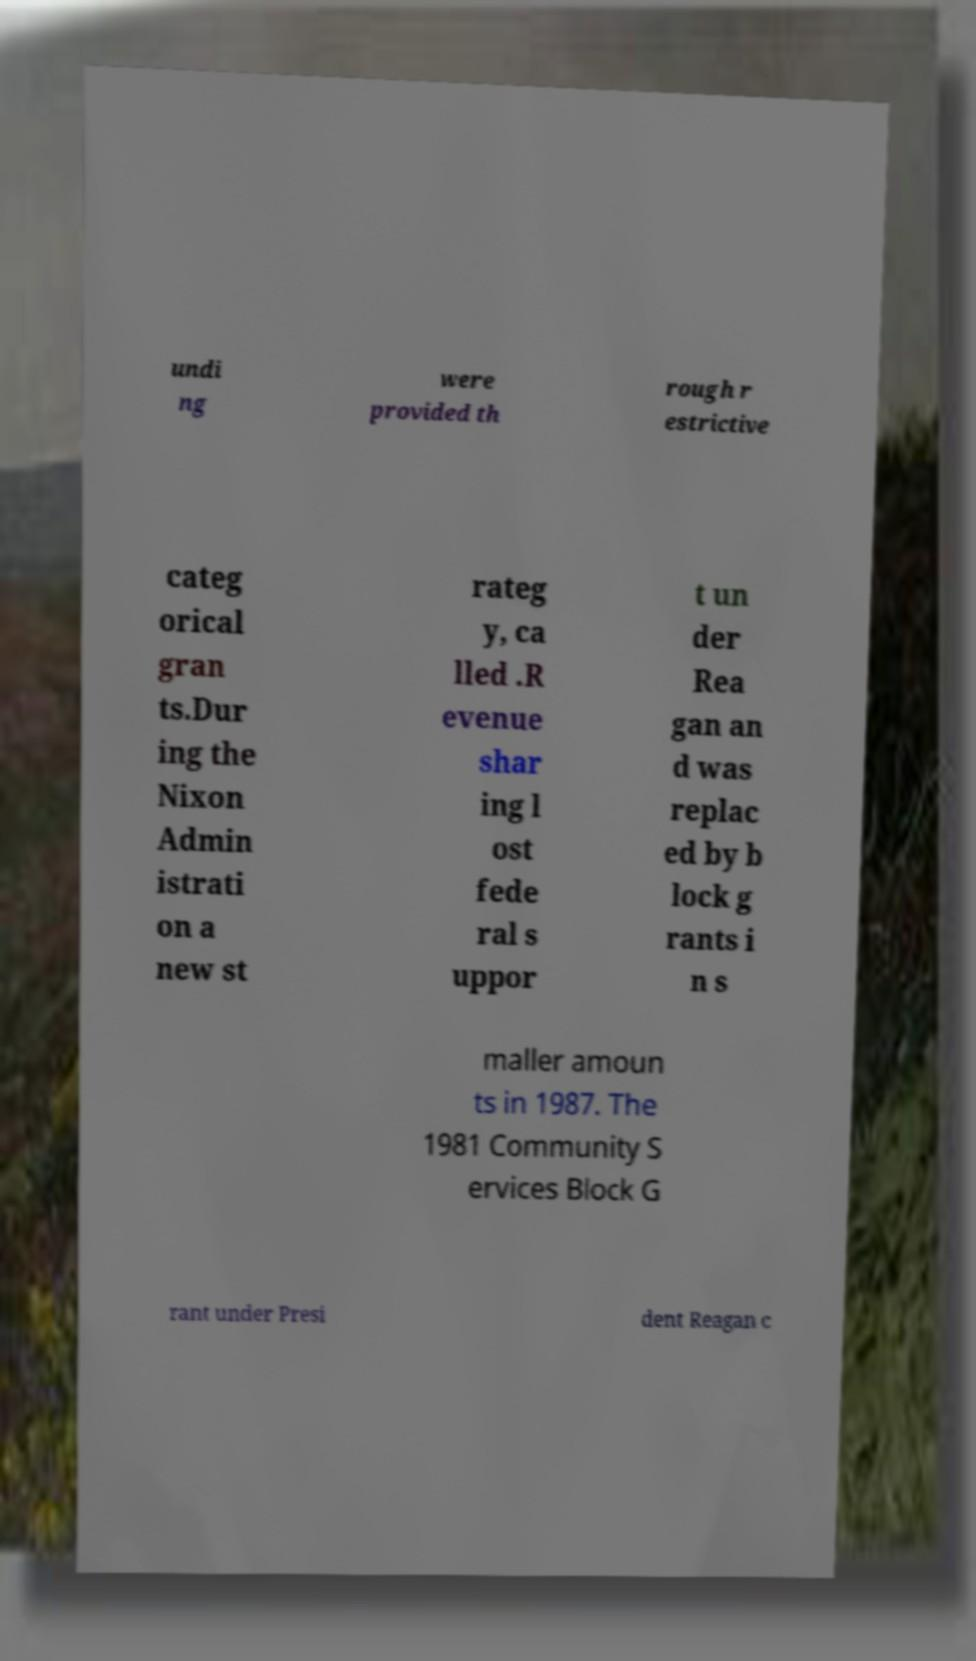Could you assist in decoding the text presented in this image and type it out clearly? undi ng were provided th rough r estrictive categ orical gran ts.Dur ing the Nixon Admin istrati on a new st rateg y, ca lled .R evenue shar ing l ost fede ral s uppor t un der Rea gan an d was replac ed by b lock g rants i n s maller amoun ts in 1987. The 1981 Community S ervices Block G rant under Presi dent Reagan c 